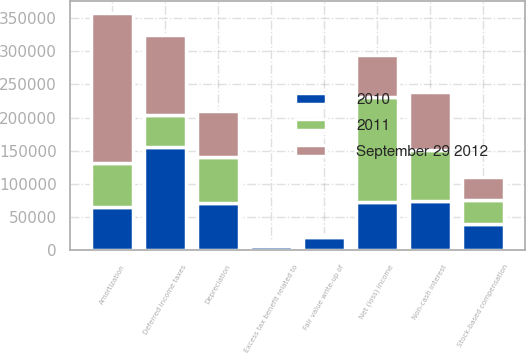Convert chart. <chart><loc_0><loc_0><loc_500><loc_500><stacked_bar_chart><ecel><fcel>Net (loss) income<fcel>Depreciation<fcel>Amortization<fcel>Non-cash interest<fcel>Stock-based compensation<fcel>Excess tax benefit related to<fcel>Deferred income taxes<fcel>Fair value write-up of<nl><fcel>2010<fcel>73634<fcel>71851<fcel>65638<fcel>74974<fcel>40572<fcel>6206<fcel>155192<fcel>19918<nl><fcel>2011<fcel>157150<fcel>68946<fcel>65638<fcel>76814<fcel>35472<fcel>3652<fcel>48107<fcel>3298<nl><fcel>September 29 2012<fcel>62813<fcel>68463<fcel>226305<fcel>86638<fcel>34160<fcel>2043<fcel>121726<fcel>732<nl></chart> 